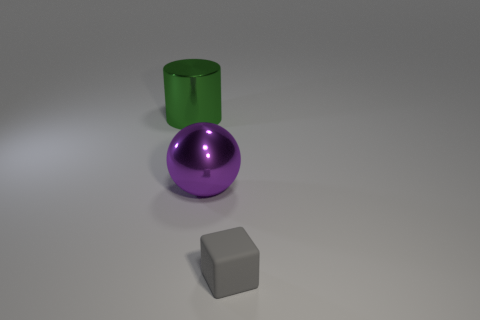Add 2 tiny gray metallic objects. How many objects exist? 5 Subtract all cylinders. How many objects are left? 2 Subtract all small gray cylinders. Subtract all small blocks. How many objects are left? 2 Add 2 metallic balls. How many metallic balls are left? 3 Add 1 purple metallic objects. How many purple metallic objects exist? 2 Subtract 0 blue blocks. How many objects are left? 3 